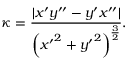Convert formula to latex. <formula><loc_0><loc_0><loc_500><loc_500>\kappa = { \frac { | x ^ { \prime } y ^ { \prime \prime } - y ^ { \prime } x ^ { \prime \prime } | } { \left ( { x ^ { \prime } } ^ { 2 } + { y ^ { \prime } } ^ { 2 } \right ) ^ { \frac { 3 } { 2 } } } } .</formula> 